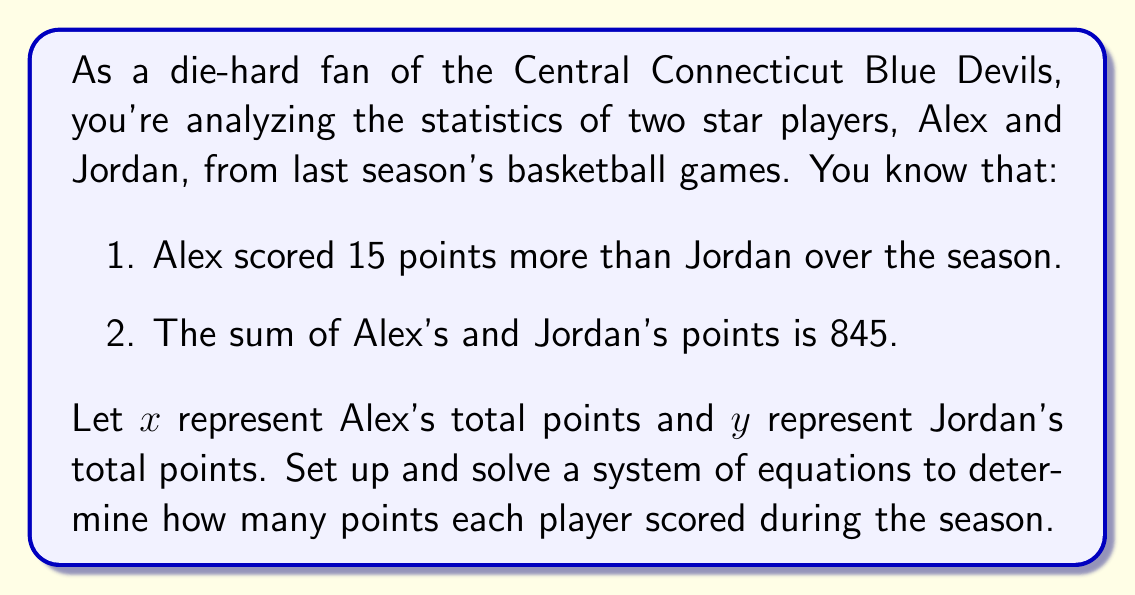Can you answer this question? Let's approach this step-by-step:

1) First, let's set up our system of equations based on the given information:

   Equation 1: $x = y + 15$ (Alex scored 15 points more than Jordan)
   Equation 2: $x + y = 845$ (The sum of their points is 845)

2) We can solve this system using substitution. Let's substitute the expression for $x$ from Equation 1 into Equation 2:

   $(y + 15) + y = 845$

3) Simplify:

   $2y + 15 = 845$

4) Subtract 15 from both sides:

   $2y = 830$

5) Divide both sides by 2:

   $y = 415$

6) Now that we know $y$ (Jordan's points), we can find $x$ (Alex's points) using Equation 1:

   $x = y + 15 = 415 + 15 = 430$

7) Let's verify our solution by checking it in both original equations:

   Equation 1: $430 = 415 + 15$ ✓
   Equation 2: $430 + 415 = 845$ ✓

Therefore, Alex scored 430 points and Jordan scored 415 points during the season.
Answer: Alex scored 430 points and Jordan scored 415 points. 